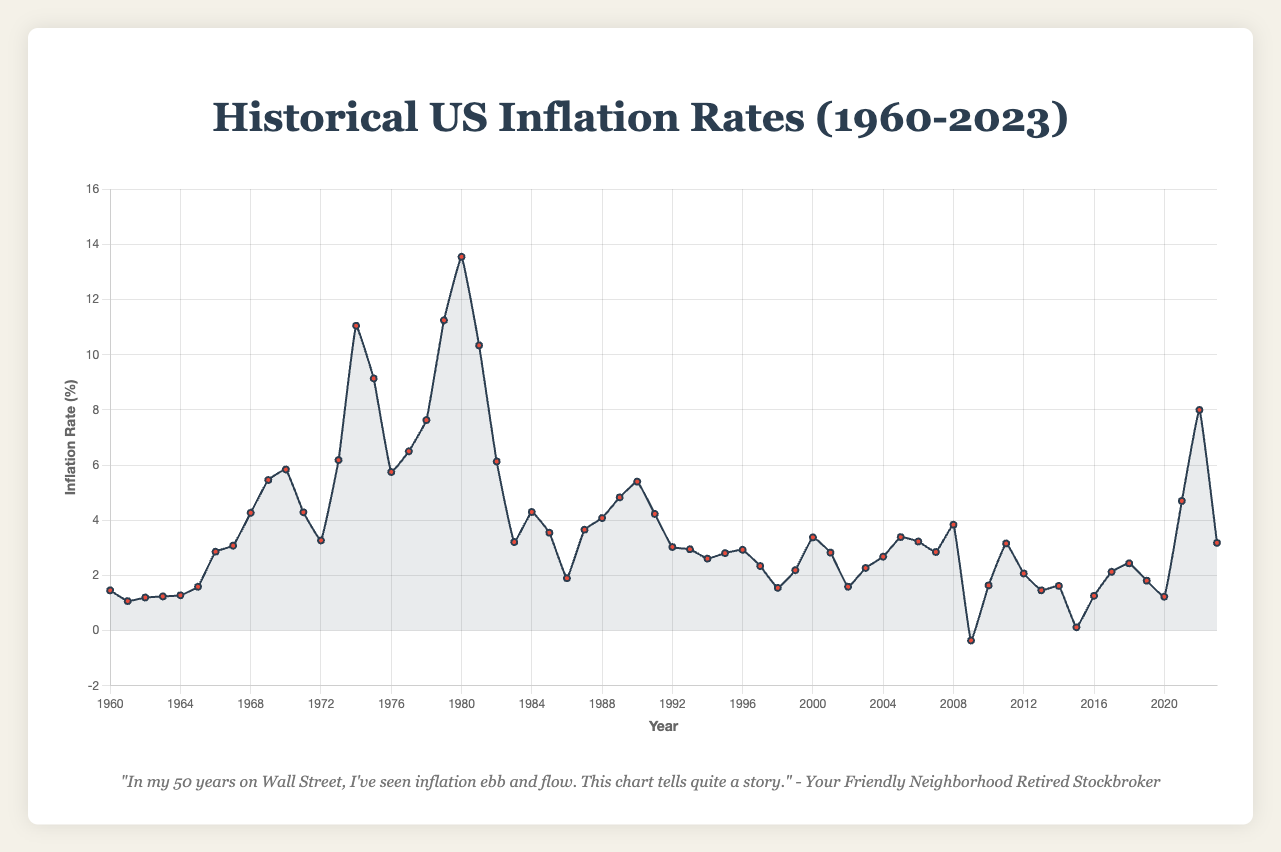What year had the highest inflation rate? The year with the highest peak in the line chart represents the year with the highest inflation rate. In the chart, this peak is in 1980.
Answer: 1980 How did the inflation rate in 2022 compare to 2021? By locating 2022 and 2021 on the x-axis and comparing their corresponding y-values, we see that the inflation rate in 2022 is higher than in 2021.
Answer: Higher What is the difference in inflation rates between 1974 and 1975? Reading the y-values for 1974 (11.05%) and 1975 (9.14%) and subtracting the latter from the former gives the difference: 11.05 - 9.14 = 1.91%.
Answer: 1.91% Identify a period of rapid inflation increase in the 1970s. A sharp rise in the inflation rate indicates rapid inflation increase. Between 1973 (6.18%) and 1974 (11.05%), there's a noticeable rapid rise in inflation.
Answer: 1973-1974 What is the average inflation rate for the decade 1990-1999? Sum up the inflation rates from 1990 to 1999: (5.40 + 4.23 + 3.03 + 2.95 + 2.61 + 2.81 + 2.93 + 2.34 + 1.55 + 2.19) and divide by the number of years (10). Sum = 32.04, Average = 32.04 / 10 = 3.204%.
Answer: 3.20% Which years had an inflation rate below 1.5%? Identify years with y-values below 1.5%: 1961 (1.07%), 1962 (1.20%), 1963 (1.24%), 1964 (1.28%), 1998 (1.55% but just above 1.5%), 2002 (1.59%), 2015 (0.12%), 2020 (1.23%).
Answer: 1961-1964, 2015, 2020 What is the trend in inflation rates from 1980 to 1983? From 1980-1983, the line graph shows a decline in the inflation rate from 13.55% (1980) to 3.21% (1983).
Answer: Decreasing 